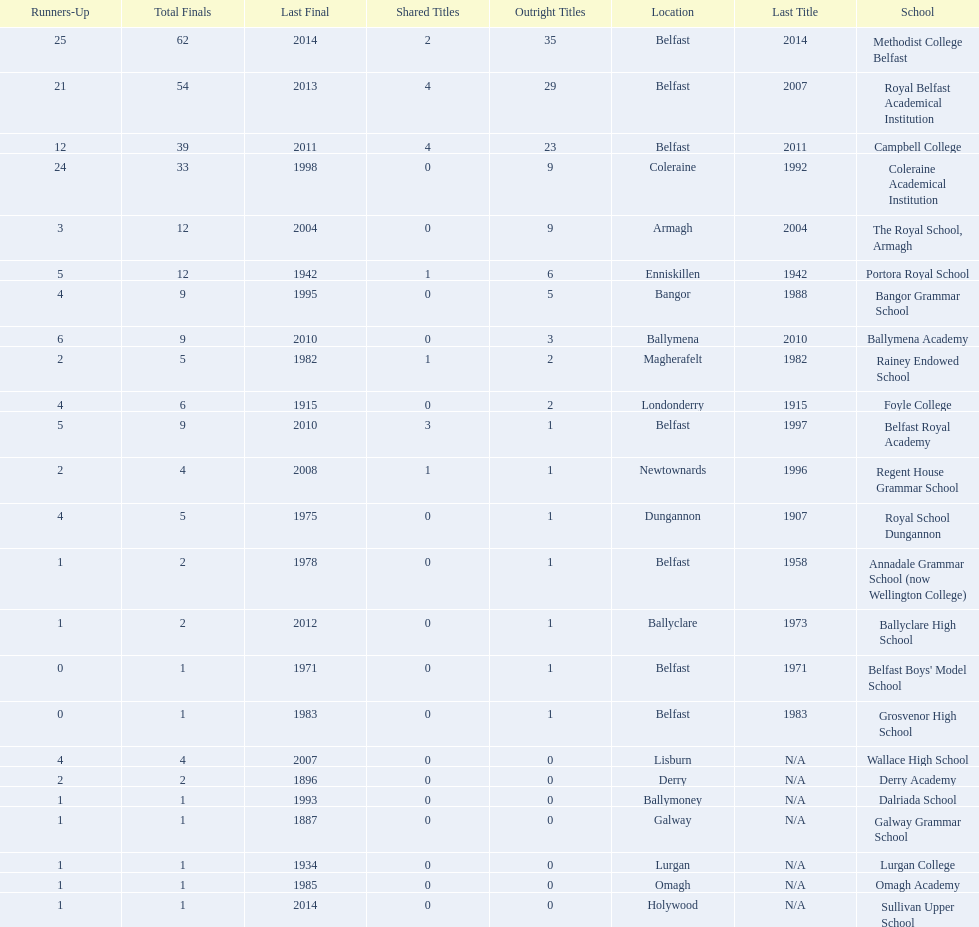What was the last year that the regent house grammar school won a title? 1996. 